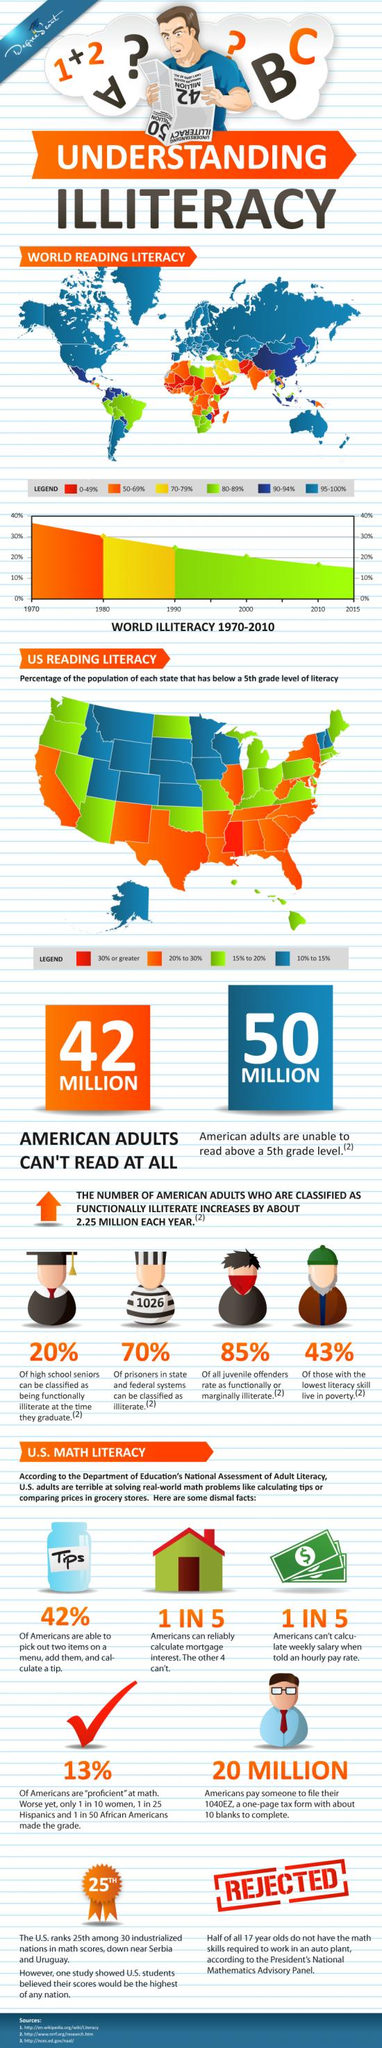List a handful of essential elements in this visual. According to a recent survey, only 13% of Americans are proficient in math. According to recent estimates, the reading literacy rate in China is approximately 90-94%. This is a high level of literacy, indicating that a majority of the population is able to read and understand written material. However, it is important to note that there may be variations in literacy rates across different regions and demographic groups within China. Approximately 20% to 30% of the population in Texas have a below fifth-grade level of literacy. According to recent estimates, approximately 15% to 20% of the population in Hawaii have below a 5th grade level of literacy. The reading literacy rate in Canada is reported to be 95-100%. 